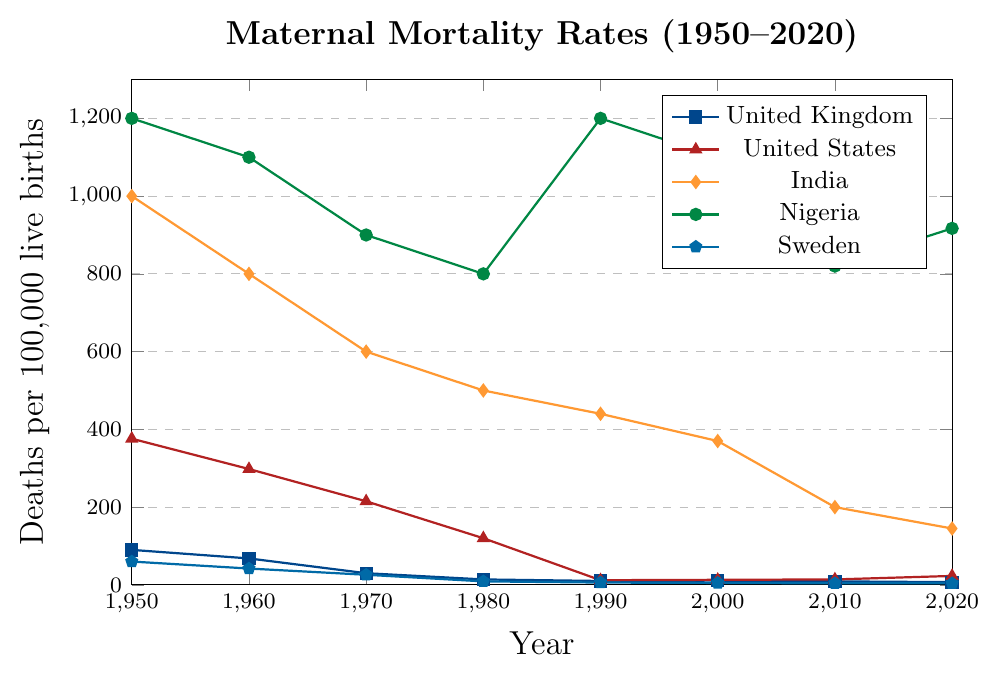What's the overall trend in maternal mortality rates in the United Kingdom from 1950 to 2020? The figure shows that the maternal mortality rates in the United Kingdom have continuously declined from 90 in 1950 to 7 in 2020. This indicates a significant reduction over the 70-year period.
Answer: Significant decline Which country had the highest maternal mortality rate in 1950? By observing the figure, Nigeria had the highest maternal mortality rate in 1950, with 1200 deaths per 100,000 live births.
Answer: Nigeria How did the maternal mortality rates in the United States and Sweden compare in 2020? In 2020, the maternal mortality rate in the United States was 23, while in Sweden it was 4. This indicates that the rate in the United States was higher than in Sweden.
Answer: The US rate was higher Which decade saw the largest drop in maternal mortality rates for India? By comparing the figure across decades for India, the largest drop is seen between 2000 (370) and 2010 (200), resulting in a decrease of 170 deaths per 100,000 live births.
Answer: 2000 to 2010 In 1990, were the maternal mortality rates higher in Nigeria or India? According to the figure, in 1990, Nigeria had a maternal mortality rate of 1200, while India had a rate of 440. Thus, Nigeria's rate was higher.
Answer: Nigeria How did the maternal mortality rate in Nigeria change from 1990 to 2000? The figure shows that the maternal mortality rate in Nigeria decreased from 1200 in 1990 to 1100 in 2000.
Answer: Decreased By how much did the maternal mortality rate for the United States decrease from 1950 to 1980? The rate in the United States in 1950 was 376 and in 1980 it was 120. The change is 376 - 120 = 256.
Answer: 256 Which countries had their maternal mortality rates drop to single digits by 1980? By observing the figure, both the United Kingdom (14) and Sweden (9) had dropped to single digits by 1980.
Answer: Sweden Which country had the smallest decrease in maternal mortality rates from 1950 to 2020? Nigeria had a decrease from 1200 in 1950 to 917 in 2020, a change of 283. Comparing all countries, this is the smallest numerical decrease.
Answer: Nigeria How did the maternal mortality rate in India change between 1970 and 2020? What percentage decrease does this represent? The rate in India was 600 in 1970 and 145 in 2020. The decrease is 600 - 145 = 455. The percentage decrease is (455/600) * 100 = 75.83%.
Answer: 75.83% 